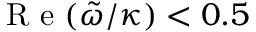<formula> <loc_0><loc_0><loc_500><loc_500>R e ( \tilde { \omega } / \kappa ) < 0 . 5</formula> 